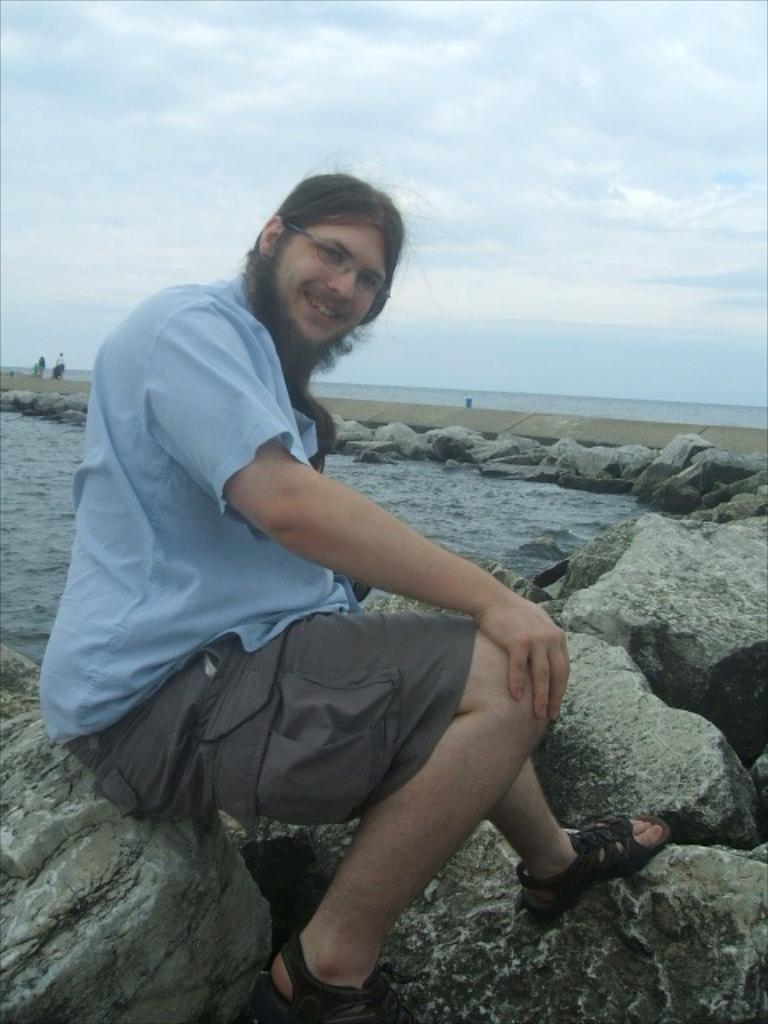What is the person in the image doing? There is a person sitting on a rock in the image. What else can be seen in the image besides the person? There are rocks visible in the background of the image, and there is water in the image. What is visible at the top of the image? The sky is visible at the top of the image. What type of cream is the person using to quiver while reading in the image? There is no cream, quivering, or reading present in the image. The person is simply sitting on a rock. 